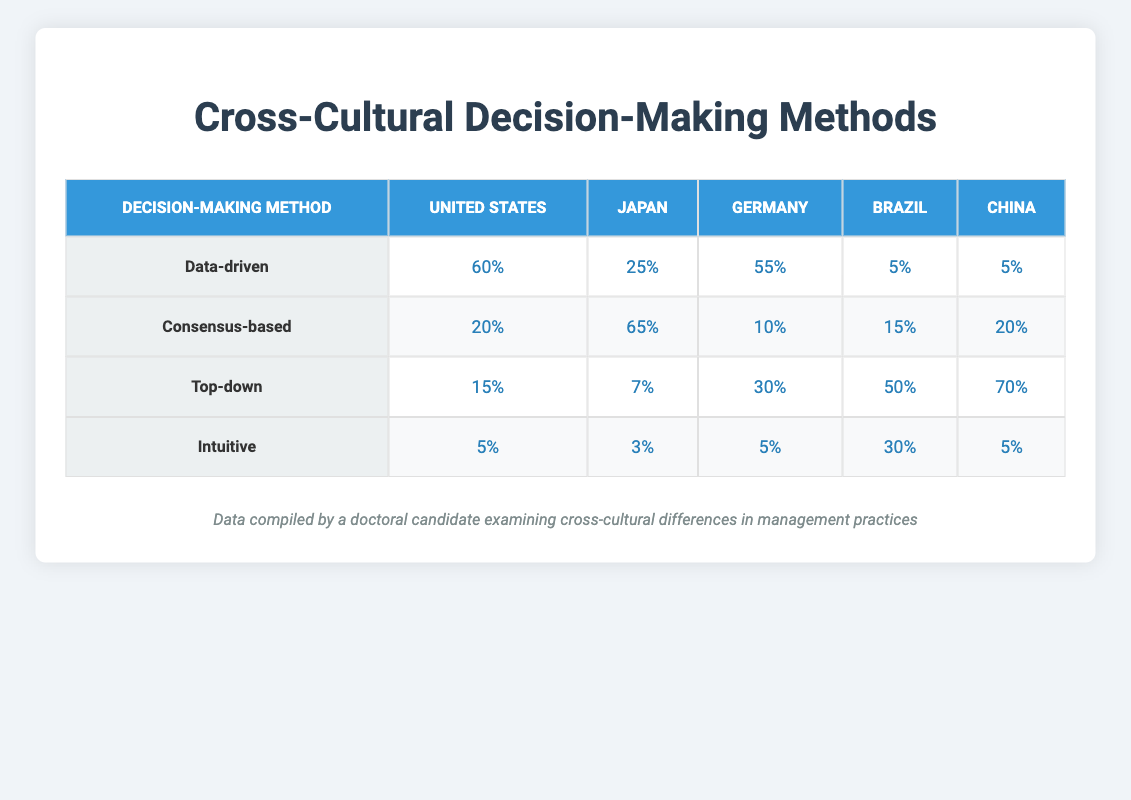What is the preference percentage for the "Data-driven" decision-making method in the United States? The table indicates that the preference percentage for the "Data-driven" method in the United States is 60%.
Answer: 60% Which cultural context shows the highest preference for the "Consensus-based" method? By comparing the percentages from the table, Japan has the highest preference for the "Consensus-based" method at 65%.
Answer: Japan What is the total preference percentage for "Top-down" decision-making across all cultural contexts? Adding the percentage values for "Top-down" from each cultural context: United States (15%) + Japan (7%) + Germany (30%) + Brazil (50%) + China (70%) = 15 + 7 + 30 + 50 + 70 = 172%.
Answer: 172% Is it true that "Intuitive" decision-making has the lowest preference in the United States? Looking at the table, the "Intuitive" method has a preference of 5% in the United States, which is indeed lower than the other methods listed.
Answer: Yes What method is preferred the most in China and how does its percentage compare to the same method in Brazil? The preferred method in China is "Top-down" with a percentage of 70%. In Brazil, the "Top-down" method has a preference percentage of 50%. The preference in China is 20% higher than in Brazil.
Answer: 20% higher 